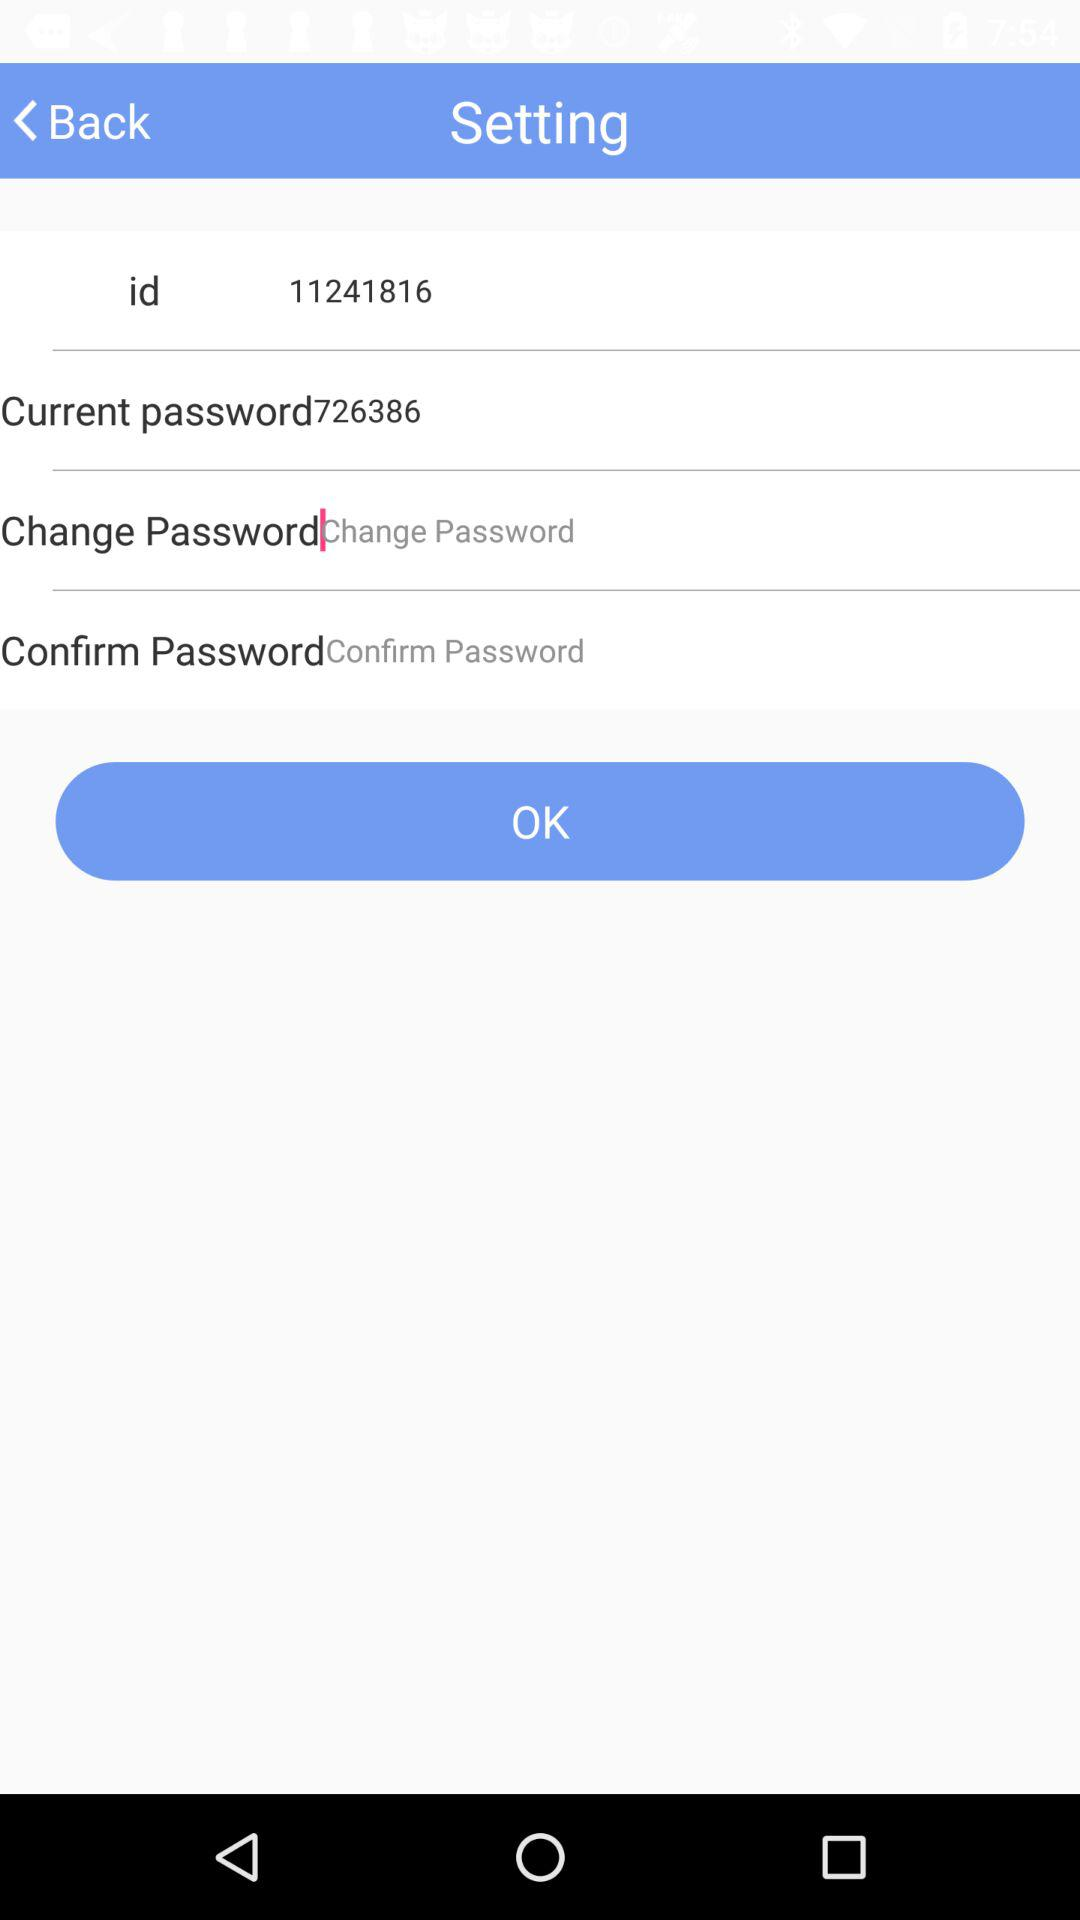What is the current password? The current password is 726386. 